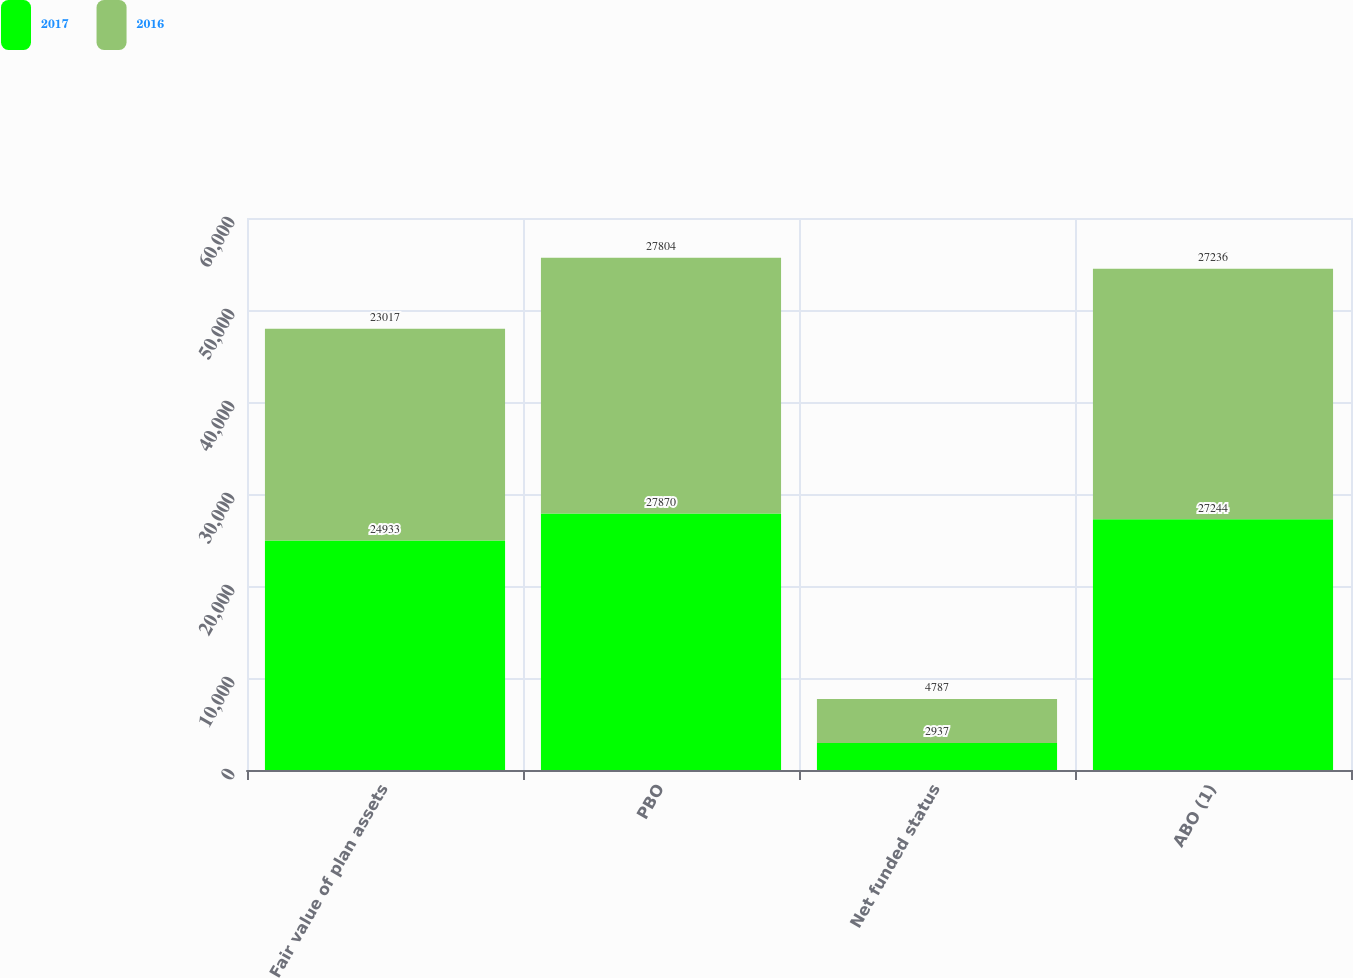Convert chart to OTSL. <chart><loc_0><loc_0><loc_500><loc_500><stacked_bar_chart><ecel><fcel>Fair value of plan assets<fcel>PBO<fcel>Net funded status<fcel>ABO (1)<nl><fcel>2017<fcel>24933<fcel>27870<fcel>2937<fcel>27244<nl><fcel>2016<fcel>23017<fcel>27804<fcel>4787<fcel>27236<nl></chart> 